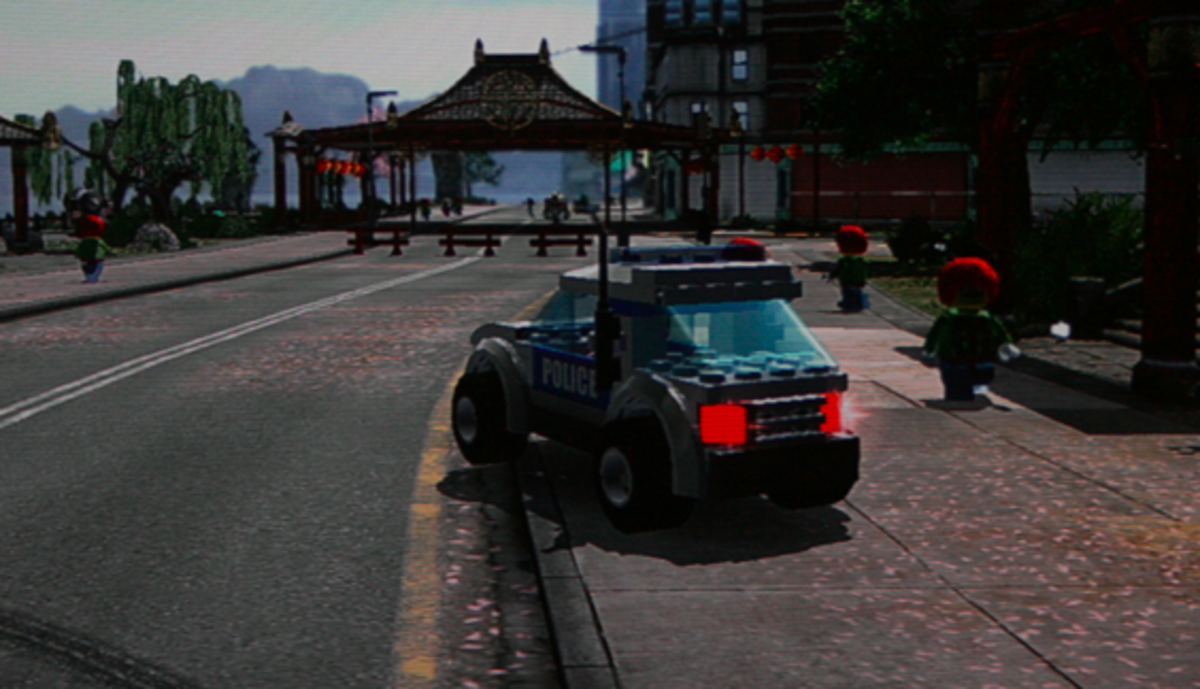Can you describe how the game might leverage its visual simplicity to attract its audience? The game's visual simplicity, characterized by clear, blocky graphics and bright colors, makes it visually accessible and less intimidating for new or young players. This simplicity helps reduce the cognitive load required to understand and engage with the game mechanics, making it more inviting and enjoyable. Moreover, this style can be particularly effective in drawing in audiences who prefer straightforward, uncomplicated gameplay that focuses more on fun and creative expression than on high-stakes competition or intricate storylines. 